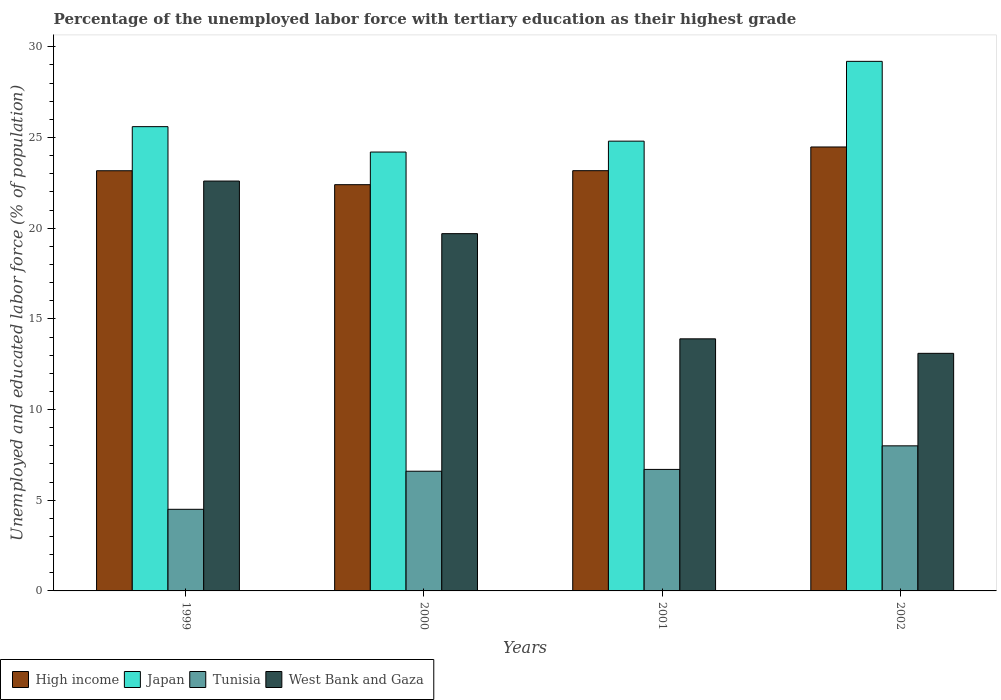How many bars are there on the 4th tick from the right?
Ensure brevity in your answer.  4. In how many cases, is the number of bars for a given year not equal to the number of legend labels?
Provide a succinct answer. 0. What is the percentage of the unemployed labor force with tertiary education in Japan in 2002?
Your answer should be very brief. 29.2. Across all years, what is the maximum percentage of the unemployed labor force with tertiary education in Japan?
Provide a short and direct response. 29.2. Across all years, what is the minimum percentage of the unemployed labor force with tertiary education in High income?
Offer a very short reply. 22.4. In which year was the percentage of the unemployed labor force with tertiary education in West Bank and Gaza maximum?
Provide a succinct answer. 1999. What is the total percentage of the unemployed labor force with tertiary education in High income in the graph?
Provide a short and direct response. 93.22. What is the difference between the percentage of the unemployed labor force with tertiary education in West Bank and Gaza in 2001 and that in 2002?
Ensure brevity in your answer.  0.8. What is the difference between the percentage of the unemployed labor force with tertiary education in West Bank and Gaza in 2001 and the percentage of the unemployed labor force with tertiary education in High income in 1999?
Your answer should be compact. -9.27. What is the average percentage of the unemployed labor force with tertiary education in Japan per year?
Give a very brief answer. 25.95. In the year 2001, what is the difference between the percentage of the unemployed labor force with tertiary education in High income and percentage of the unemployed labor force with tertiary education in Japan?
Provide a succinct answer. -1.63. In how many years, is the percentage of the unemployed labor force with tertiary education in Japan greater than 5 %?
Provide a short and direct response. 4. What is the ratio of the percentage of the unemployed labor force with tertiary education in West Bank and Gaza in 1999 to that in 2002?
Offer a very short reply. 1.73. Is the difference between the percentage of the unemployed labor force with tertiary education in High income in 1999 and 2002 greater than the difference between the percentage of the unemployed labor force with tertiary education in Japan in 1999 and 2002?
Your response must be concise. Yes. What is the difference between the highest and the second highest percentage of the unemployed labor force with tertiary education in West Bank and Gaza?
Offer a very short reply. 2.9. What is the difference between the highest and the lowest percentage of the unemployed labor force with tertiary education in Tunisia?
Provide a short and direct response. 3.5. Is the sum of the percentage of the unemployed labor force with tertiary education in High income in 1999 and 2000 greater than the maximum percentage of the unemployed labor force with tertiary education in West Bank and Gaza across all years?
Your answer should be very brief. Yes. Is it the case that in every year, the sum of the percentage of the unemployed labor force with tertiary education in High income and percentage of the unemployed labor force with tertiary education in Tunisia is greater than the sum of percentage of the unemployed labor force with tertiary education in Japan and percentage of the unemployed labor force with tertiary education in West Bank and Gaza?
Provide a short and direct response. No. What does the 4th bar from the left in 2001 represents?
Offer a terse response. West Bank and Gaza. What does the 2nd bar from the right in 2001 represents?
Your answer should be compact. Tunisia. Is it the case that in every year, the sum of the percentage of the unemployed labor force with tertiary education in High income and percentage of the unemployed labor force with tertiary education in West Bank and Gaza is greater than the percentage of the unemployed labor force with tertiary education in Tunisia?
Offer a terse response. Yes. How many years are there in the graph?
Keep it short and to the point. 4. Are the values on the major ticks of Y-axis written in scientific E-notation?
Your response must be concise. No. Does the graph contain any zero values?
Offer a terse response. No. Does the graph contain grids?
Ensure brevity in your answer.  No. How many legend labels are there?
Ensure brevity in your answer.  4. What is the title of the graph?
Provide a short and direct response. Percentage of the unemployed labor force with tertiary education as their highest grade. Does "Portugal" appear as one of the legend labels in the graph?
Keep it short and to the point. No. What is the label or title of the X-axis?
Your response must be concise. Years. What is the label or title of the Y-axis?
Your response must be concise. Unemployed and educated labor force (% of population). What is the Unemployed and educated labor force (% of population) in High income in 1999?
Make the answer very short. 23.17. What is the Unemployed and educated labor force (% of population) of Japan in 1999?
Provide a succinct answer. 25.6. What is the Unemployed and educated labor force (% of population) in Tunisia in 1999?
Offer a terse response. 4.5. What is the Unemployed and educated labor force (% of population) in West Bank and Gaza in 1999?
Your answer should be very brief. 22.6. What is the Unemployed and educated labor force (% of population) in High income in 2000?
Your response must be concise. 22.4. What is the Unemployed and educated labor force (% of population) in Japan in 2000?
Make the answer very short. 24.2. What is the Unemployed and educated labor force (% of population) of Tunisia in 2000?
Ensure brevity in your answer.  6.6. What is the Unemployed and educated labor force (% of population) of West Bank and Gaza in 2000?
Your answer should be compact. 19.7. What is the Unemployed and educated labor force (% of population) of High income in 2001?
Offer a terse response. 23.17. What is the Unemployed and educated labor force (% of population) in Japan in 2001?
Your response must be concise. 24.8. What is the Unemployed and educated labor force (% of population) in Tunisia in 2001?
Provide a short and direct response. 6.7. What is the Unemployed and educated labor force (% of population) of West Bank and Gaza in 2001?
Your answer should be compact. 13.9. What is the Unemployed and educated labor force (% of population) in High income in 2002?
Provide a succinct answer. 24.48. What is the Unemployed and educated labor force (% of population) in Japan in 2002?
Your answer should be compact. 29.2. What is the Unemployed and educated labor force (% of population) of West Bank and Gaza in 2002?
Your answer should be compact. 13.1. Across all years, what is the maximum Unemployed and educated labor force (% of population) of High income?
Keep it short and to the point. 24.48. Across all years, what is the maximum Unemployed and educated labor force (% of population) of Japan?
Your response must be concise. 29.2. Across all years, what is the maximum Unemployed and educated labor force (% of population) in Tunisia?
Give a very brief answer. 8. Across all years, what is the maximum Unemployed and educated labor force (% of population) in West Bank and Gaza?
Make the answer very short. 22.6. Across all years, what is the minimum Unemployed and educated labor force (% of population) in High income?
Provide a short and direct response. 22.4. Across all years, what is the minimum Unemployed and educated labor force (% of population) of Japan?
Your answer should be very brief. 24.2. Across all years, what is the minimum Unemployed and educated labor force (% of population) in Tunisia?
Ensure brevity in your answer.  4.5. Across all years, what is the minimum Unemployed and educated labor force (% of population) in West Bank and Gaza?
Keep it short and to the point. 13.1. What is the total Unemployed and educated labor force (% of population) of High income in the graph?
Offer a terse response. 93.22. What is the total Unemployed and educated labor force (% of population) of Japan in the graph?
Provide a short and direct response. 103.8. What is the total Unemployed and educated labor force (% of population) in Tunisia in the graph?
Your answer should be compact. 25.8. What is the total Unemployed and educated labor force (% of population) of West Bank and Gaza in the graph?
Offer a terse response. 69.3. What is the difference between the Unemployed and educated labor force (% of population) of High income in 1999 and that in 2000?
Make the answer very short. 0.77. What is the difference between the Unemployed and educated labor force (% of population) of Tunisia in 1999 and that in 2000?
Ensure brevity in your answer.  -2.1. What is the difference between the Unemployed and educated labor force (% of population) in West Bank and Gaza in 1999 and that in 2000?
Keep it short and to the point. 2.9. What is the difference between the Unemployed and educated labor force (% of population) of High income in 1999 and that in 2001?
Provide a short and direct response. -0. What is the difference between the Unemployed and educated labor force (% of population) of High income in 1999 and that in 2002?
Ensure brevity in your answer.  -1.31. What is the difference between the Unemployed and educated labor force (% of population) in High income in 2000 and that in 2001?
Offer a very short reply. -0.77. What is the difference between the Unemployed and educated labor force (% of population) of Japan in 2000 and that in 2001?
Provide a succinct answer. -0.6. What is the difference between the Unemployed and educated labor force (% of population) in Tunisia in 2000 and that in 2001?
Give a very brief answer. -0.1. What is the difference between the Unemployed and educated labor force (% of population) of High income in 2000 and that in 2002?
Offer a terse response. -2.08. What is the difference between the Unemployed and educated labor force (% of population) in Tunisia in 2000 and that in 2002?
Your answer should be compact. -1.4. What is the difference between the Unemployed and educated labor force (% of population) of High income in 2001 and that in 2002?
Provide a short and direct response. -1.31. What is the difference between the Unemployed and educated labor force (% of population) of Japan in 2001 and that in 2002?
Make the answer very short. -4.4. What is the difference between the Unemployed and educated labor force (% of population) in West Bank and Gaza in 2001 and that in 2002?
Your answer should be compact. 0.8. What is the difference between the Unemployed and educated labor force (% of population) in High income in 1999 and the Unemployed and educated labor force (% of population) in Japan in 2000?
Make the answer very short. -1.03. What is the difference between the Unemployed and educated labor force (% of population) in High income in 1999 and the Unemployed and educated labor force (% of population) in Tunisia in 2000?
Offer a terse response. 16.57. What is the difference between the Unemployed and educated labor force (% of population) in High income in 1999 and the Unemployed and educated labor force (% of population) in West Bank and Gaza in 2000?
Ensure brevity in your answer.  3.47. What is the difference between the Unemployed and educated labor force (% of population) of Japan in 1999 and the Unemployed and educated labor force (% of population) of Tunisia in 2000?
Your answer should be compact. 19. What is the difference between the Unemployed and educated labor force (% of population) in Japan in 1999 and the Unemployed and educated labor force (% of population) in West Bank and Gaza in 2000?
Provide a succinct answer. 5.9. What is the difference between the Unemployed and educated labor force (% of population) of Tunisia in 1999 and the Unemployed and educated labor force (% of population) of West Bank and Gaza in 2000?
Ensure brevity in your answer.  -15.2. What is the difference between the Unemployed and educated labor force (% of population) in High income in 1999 and the Unemployed and educated labor force (% of population) in Japan in 2001?
Offer a terse response. -1.63. What is the difference between the Unemployed and educated labor force (% of population) in High income in 1999 and the Unemployed and educated labor force (% of population) in Tunisia in 2001?
Offer a terse response. 16.47. What is the difference between the Unemployed and educated labor force (% of population) of High income in 1999 and the Unemployed and educated labor force (% of population) of West Bank and Gaza in 2001?
Ensure brevity in your answer.  9.27. What is the difference between the Unemployed and educated labor force (% of population) in Japan in 1999 and the Unemployed and educated labor force (% of population) in West Bank and Gaza in 2001?
Offer a very short reply. 11.7. What is the difference between the Unemployed and educated labor force (% of population) in Tunisia in 1999 and the Unemployed and educated labor force (% of population) in West Bank and Gaza in 2001?
Offer a very short reply. -9.4. What is the difference between the Unemployed and educated labor force (% of population) in High income in 1999 and the Unemployed and educated labor force (% of population) in Japan in 2002?
Provide a short and direct response. -6.03. What is the difference between the Unemployed and educated labor force (% of population) in High income in 1999 and the Unemployed and educated labor force (% of population) in Tunisia in 2002?
Provide a short and direct response. 15.17. What is the difference between the Unemployed and educated labor force (% of population) of High income in 1999 and the Unemployed and educated labor force (% of population) of West Bank and Gaza in 2002?
Make the answer very short. 10.07. What is the difference between the Unemployed and educated labor force (% of population) of Japan in 1999 and the Unemployed and educated labor force (% of population) of Tunisia in 2002?
Offer a terse response. 17.6. What is the difference between the Unemployed and educated labor force (% of population) in Tunisia in 1999 and the Unemployed and educated labor force (% of population) in West Bank and Gaza in 2002?
Provide a succinct answer. -8.6. What is the difference between the Unemployed and educated labor force (% of population) in High income in 2000 and the Unemployed and educated labor force (% of population) in Japan in 2001?
Keep it short and to the point. -2.4. What is the difference between the Unemployed and educated labor force (% of population) of High income in 2000 and the Unemployed and educated labor force (% of population) of Tunisia in 2001?
Ensure brevity in your answer.  15.7. What is the difference between the Unemployed and educated labor force (% of population) of High income in 2000 and the Unemployed and educated labor force (% of population) of West Bank and Gaza in 2001?
Your answer should be very brief. 8.5. What is the difference between the Unemployed and educated labor force (% of population) of High income in 2000 and the Unemployed and educated labor force (% of population) of Japan in 2002?
Your answer should be compact. -6.8. What is the difference between the Unemployed and educated labor force (% of population) in High income in 2000 and the Unemployed and educated labor force (% of population) in Tunisia in 2002?
Offer a terse response. 14.4. What is the difference between the Unemployed and educated labor force (% of population) in High income in 2000 and the Unemployed and educated labor force (% of population) in West Bank and Gaza in 2002?
Give a very brief answer. 9.3. What is the difference between the Unemployed and educated labor force (% of population) in Tunisia in 2000 and the Unemployed and educated labor force (% of population) in West Bank and Gaza in 2002?
Your response must be concise. -6.5. What is the difference between the Unemployed and educated labor force (% of population) in High income in 2001 and the Unemployed and educated labor force (% of population) in Japan in 2002?
Your answer should be compact. -6.03. What is the difference between the Unemployed and educated labor force (% of population) in High income in 2001 and the Unemployed and educated labor force (% of population) in Tunisia in 2002?
Provide a short and direct response. 15.17. What is the difference between the Unemployed and educated labor force (% of population) of High income in 2001 and the Unemployed and educated labor force (% of population) of West Bank and Gaza in 2002?
Ensure brevity in your answer.  10.07. What is the difference between the Unemployed and educated labor force (% of population) in Japan in 2001 and the Unemployed and educated labor force (% of population) in West Bank and Gaza in 2002?
Provide a short and direct response. 11.7. What is the difference between the Unemployed and educated labor force (% of population) in Tunisia in 2001 and the Unemployed and educated labor force (% of population) in West Bank and Gaza in 2002?
Keep it short and to the point. -6.4. What is the average Unemployed and educated labor force (% of population) of High income per year?
Provide a short and direct response. 23.3. What is the average Unemployed and educated labor force (% of population) in Japan per year?
Provide a short and direct response. 25.95. What is the average Unemployed and educated labor force (% of population) in Tunisia per year?
Your answer should be very brief. 6.45. What is the average Unemployed and educated labor force (% of population) of West Bank and Gaza per year?
Your response must be concise. 17.32. In the year 1999, what is the difference between the Unemployed and educated labor force (% of population) in High income and Unemployed and educated labor force (% of population) in Japan?
Ensure brevity in your answer.  -2.43. In the year 1999, what is the difference between the Unemployed and educated labor force (% of population) of High income and Unemployed and educated labor force (% of population) of Tunisia?
Give a very brief answer. 18.67. In the year 1999, what is the difference between the Unemployed and educated labor force (% of population) in High income and Unemployed and educated labor force (% of population) in West Bank and Gaza?
Your response must be concise. 0.57. In the year 1999, what is the difference between the Unemployed and educated labor force (% of population) of Japan and Unemployed and educated labor force (% of population) of Tunisia?
Provide a short and direct response. 21.1. In the year 1999, what is the difference between the Unemployed and educated labor force (% of population) of Tunisia and Unemployed and educated labor force (% of population) of West Bank and Gaza?
Offer a very short reply. -18.1. In the year 2000, what is the difference between the Unemployed and educated labor force (% of population) in High income and Unemployed and educated labor force (% of population) in Japan?
Ensure brevity in your answer.  -1.8. In the year 2000, what is the difference between the Unemployed and educated labor force (% of population) of High income and Unemployed and educated labor force (% of population) of Tunisia?
Keep it short and to the point. 15.8. In the year 2000, what is the difference between the Unemployed and educated labor force (% of population) in High income and Unemployed and educated labor force (% of population) in West Bank and Gaza?
Your answer should be compact. 2.7. In the year 2001, what is the difference between the Unemployed and educated labor force (% of population) in High income and Unemployed and educated labor force (% of population) in Japan?
Make the answer very short. -1.63. In the year 2001, what is the difference between the Unemployed and educated labor force (% of population) in High income and Unemployed and educated labor force (% of population) in Tunisia?
Give a very brief answer. 16.47. In the year 2001, what is the difference between the Unemployed and educated labor force (% of population) of High income and Unemployed and educated labor force (% of population) of West Bank and Gaza?
Ensure brevity in your answer.  9.27. In the year 2001, what is the difference between the Unemployed and educated labor force (% of population) of Japan and Unemployed and educated labor force (% of population) of Tunisia?
Your answer should be compact. 18.1. In the year 2001, what is the difference between the Unemployed and educated labor force (% of population) in Tunisia and Unemployed and educated labor force (% of population) in West Bank and Gaza?
Your answer should be compact. -7.2. In the year 2002, what is the difference between the Unemployed and educated labor force (% of population) of High income and Unemployed and educated labor force (% of population) of Japan?
Make the answer very short. -4.72. In the year 2002, what is the difference between the Unemployed and educated labor force (% of population) in High income and Unemployed and educated labor force (% of population) in Tunisia?
Offer a very short reply. 16.48. In the year 2002, what is the difference between the Unemployed and educated labor force (% of population) of High income and Unemployed and educated labor force (% of population) of West Bank and Gaza?
Give a very brief answer. 11.38. In the year 2002, what is the difference between the Unemployed and educated labor force (% of population) of Japan and Unemployed and educated labor force (% of population) of Tunisia?
Provide a succinct answer. 21.2. In the year 2002, what is the difference between the Unemployed and educated labor force (% of population) of Tunisia and Unemployed and educated labor force (% of population) of West Bank and Gaza?
Offer a terse response. -5.1. What is the ratio of the Unemployed and educated labor force (% of population) in High income in 1999 to that in 2000?
Your answer should be very brief. 1.03. What is the ratio of the Unemployed and educated labor force (% of population) of Japan in 1999 to that in 2000?
Your answer should be very brief. 1.06. What is the ratio of the Unemployed and educated labor force (% of population) in Tunisia in 1999 to that in 2000?
Keep it short and to the point. 0.68. What is the ratio of the Unemployed and educated labor force (% of population) in West Bank and Gaza in 1999 to that in 2000?
Your answer should be very brief. 1.15. What is the ratio of the Unemployed and educated labor force (% of population) of Japan in 1999 to that in 2001?
Offer a very short reply. 1.03. What is the ratio of the Unemployed and educated labor force (% of population) in Tunisia in 1999 to that in 2001?
Your answer should be very brief. 0.67. What is the ratio of the Unemployed and educated labor force (% of population) of West Bank and Gaza in 1999 to that in 2001?
Make the answer very short. 1.63. What is the ratio of the Unemployed and educated labor force (% of population) in High income in 1999 to that in 2002?
Provide a short and direct response. 0.95. What is the ratio of the Unemployed and educated labor force (% of population) in Japan in 1999 to that in 2002?
Your response must be concise. 0.88. What is the ratio of the Unemployed and educated labor force (% of population) in Tunisia in 1999 to that in 2002?
Your answer should be compact. 0.56. What is the ratio of the Unemployed and educated labor force (% of population) in West Bank and Gaza in 1999 to that in 2002?
Ensure brevity in your answer.  1.73. What is the ratio of the Unemployed and educated labor force (% of population) of High income in 2000 to that in 2001?
Your answer should be compact. 0.97. What is the ratio of the Unemployed and educated labor force (% of population) in Japan in 2000 to that in 2001?
Offer a very short reply. 0.98. What is the ratio of the Unemployed and educated labor force (% of population) in Tunisia in 2000 to that in 2001?
Make the answer very short. 0.99. What is the ratio of the Unemployed and educated labor force (% of population) of West Bank and Gaza in 2000 to that in 2001?
Offer a terse response. 1.42. What is the ratio of the Unemployed and educated labor force (% of population) of High income in 2000 to that in 2002?
Provide a succinct answer. 0.92. What is the ratio of the Unemployed and educated labor force (% of population) of Japan in 2000 to that in 2002?
Ensure brevity in your answer.  0.83. What is the ratio of the Unemployed and educated labor force (% of population) in Tunisia in 2000 to that in 2002?
Offer a very short reply. 0.82. What is the ratio of the Unemployed and educated labor force (% of population) of West Bank and Gaza in 2000 to that in 2002?
Your response must be concise. 1.5. What is the ratio of the Unemployed and educated labor force (% of population) of High income in 2001 to that in 2002?
Provide a short and direct response. 0.95. What is the ratio of the Unemployed and educated labor force (% of population) of Japan in 2001 to that in 2002?
Offer a terse response. 0.85. What is the ratio of the Unemployed and educated labor force (% of population) of Tunisia in 2001 to that in 2002?
Provide a succinct answer. 0.84. What is the ratio of the Unemployed and educated labor force (% of population) in West Bank and Gaza in 2001 to that in 2002?
Offer a very short reply. 1.06. What is the difference between the highest and the second highest Unemployed and educated labor force (% of population) of High income?
Your response must be concise. 1.31. What is the difference between the highest and the second highest Unemployed and educated labor force (% of population) in Japan?
Provide a short and direct response. 3.6. What is the difference between the highest and the second highest Unemployed and educated labor force (% of population) of West Bank and Gaza?
Your answer should be very brief. 2.9. What is the difference between the highest and the lowest Unemployed and educated labor force (% of population) in High income?
Make the answer very short. 2.08. What is the difference between the highest and the lowest Unemployed and educated labor force (% of population) of Japan?
Your response must be concise. 5. What is the difference between the highest and the lowest Unemployed and educated labor force (% of population) of Tunisia?
Provide a succinct answer. 3.5. What is the difference between the highest and the lowest Unemployed and educated labor force (% of population) of West Bank and Gaza?
Your response must be concise. 9.5. 